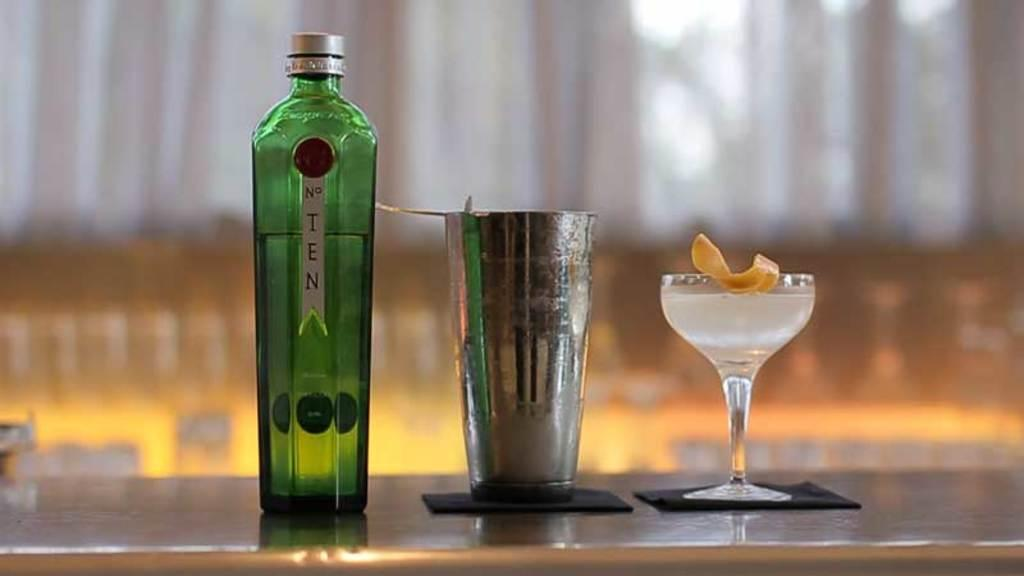Provide a one-sentence caption for the provided image. A tall bottle of No. Ten sits next to a martini shaker and a filled cocktail glass. 